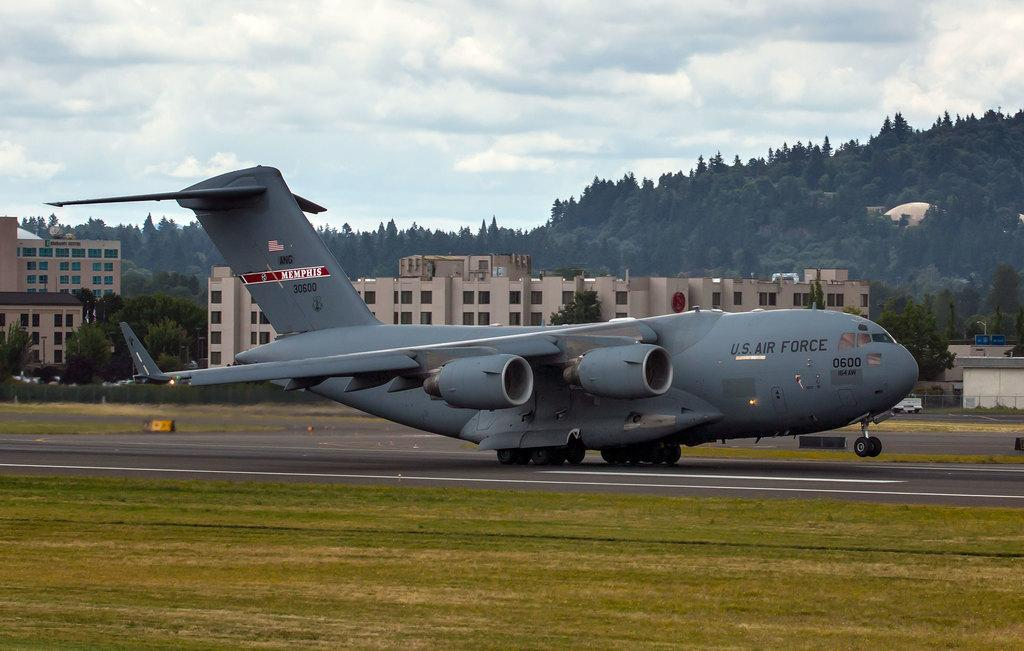<image>
Write a terse but informative summary of the picture. a plane has air force on the side of it 